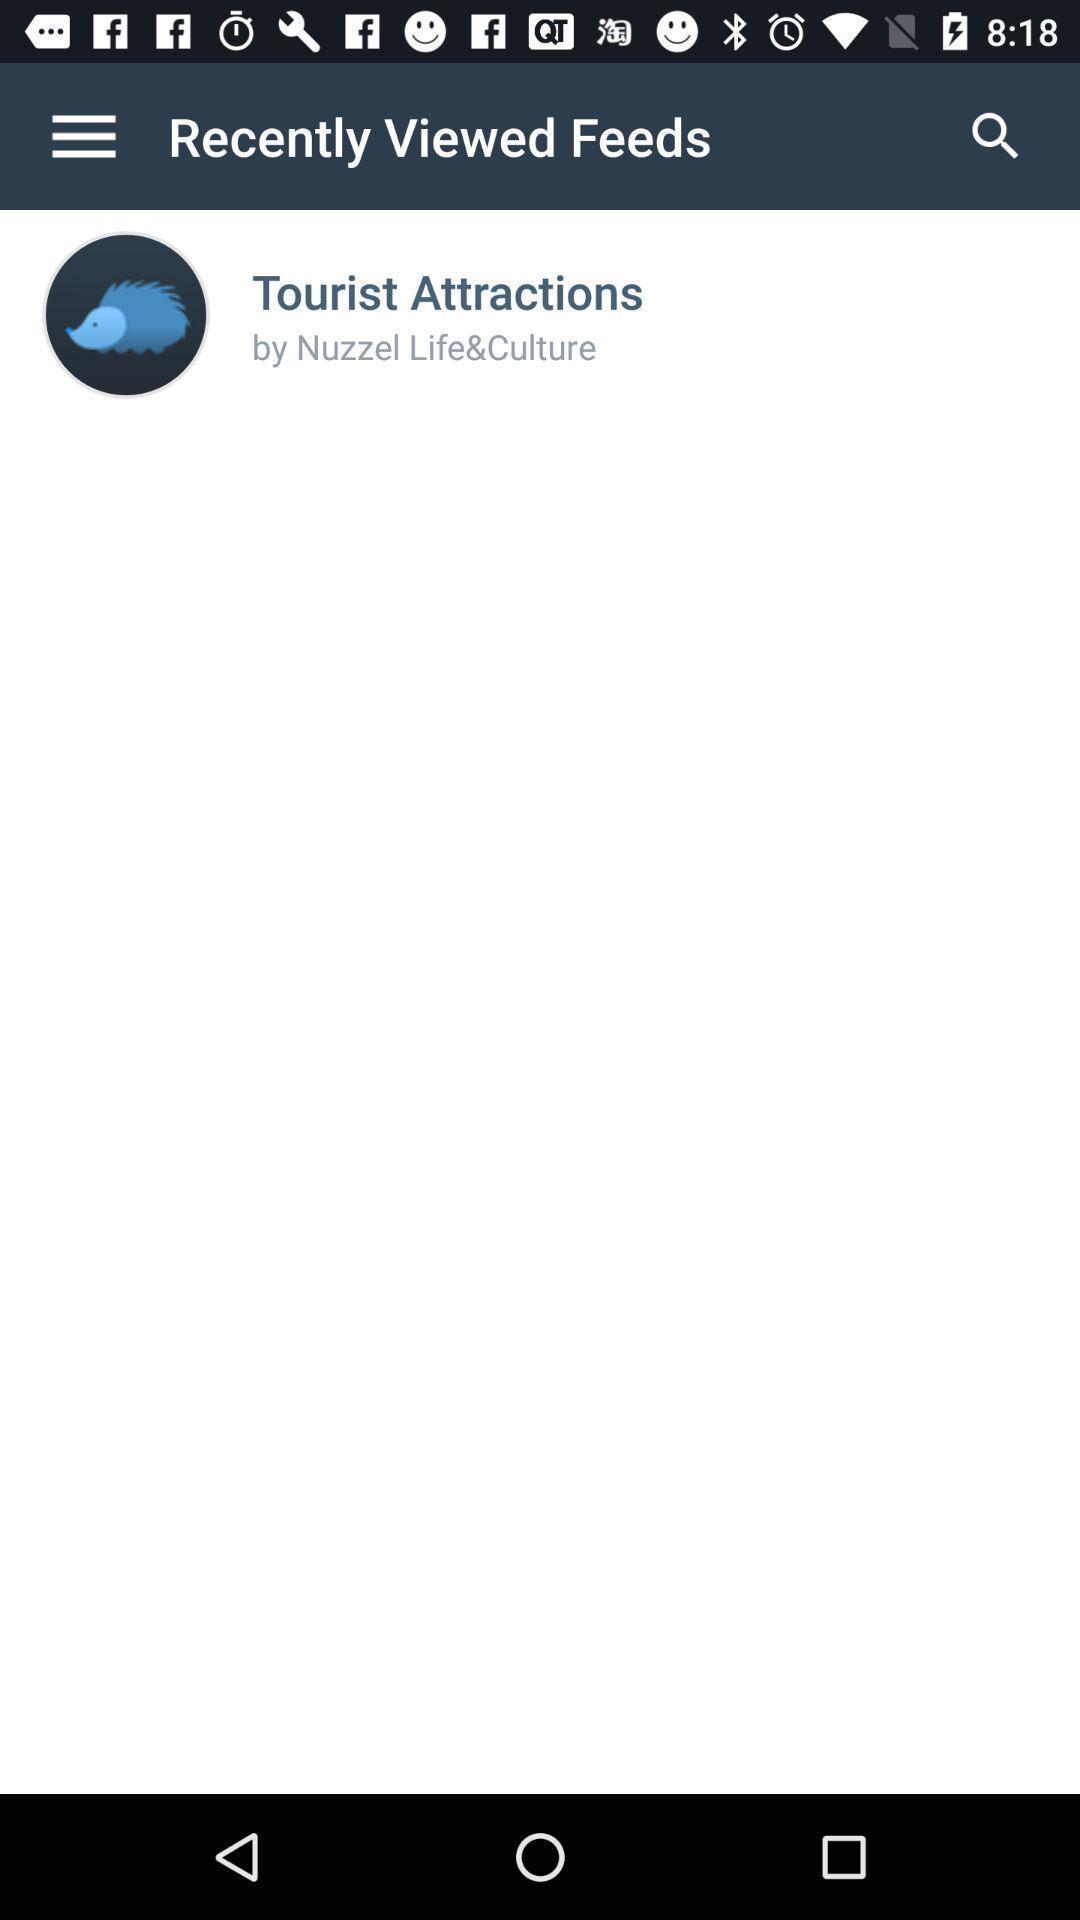Tell me what you see in this picture. Window displaying with feed page. 